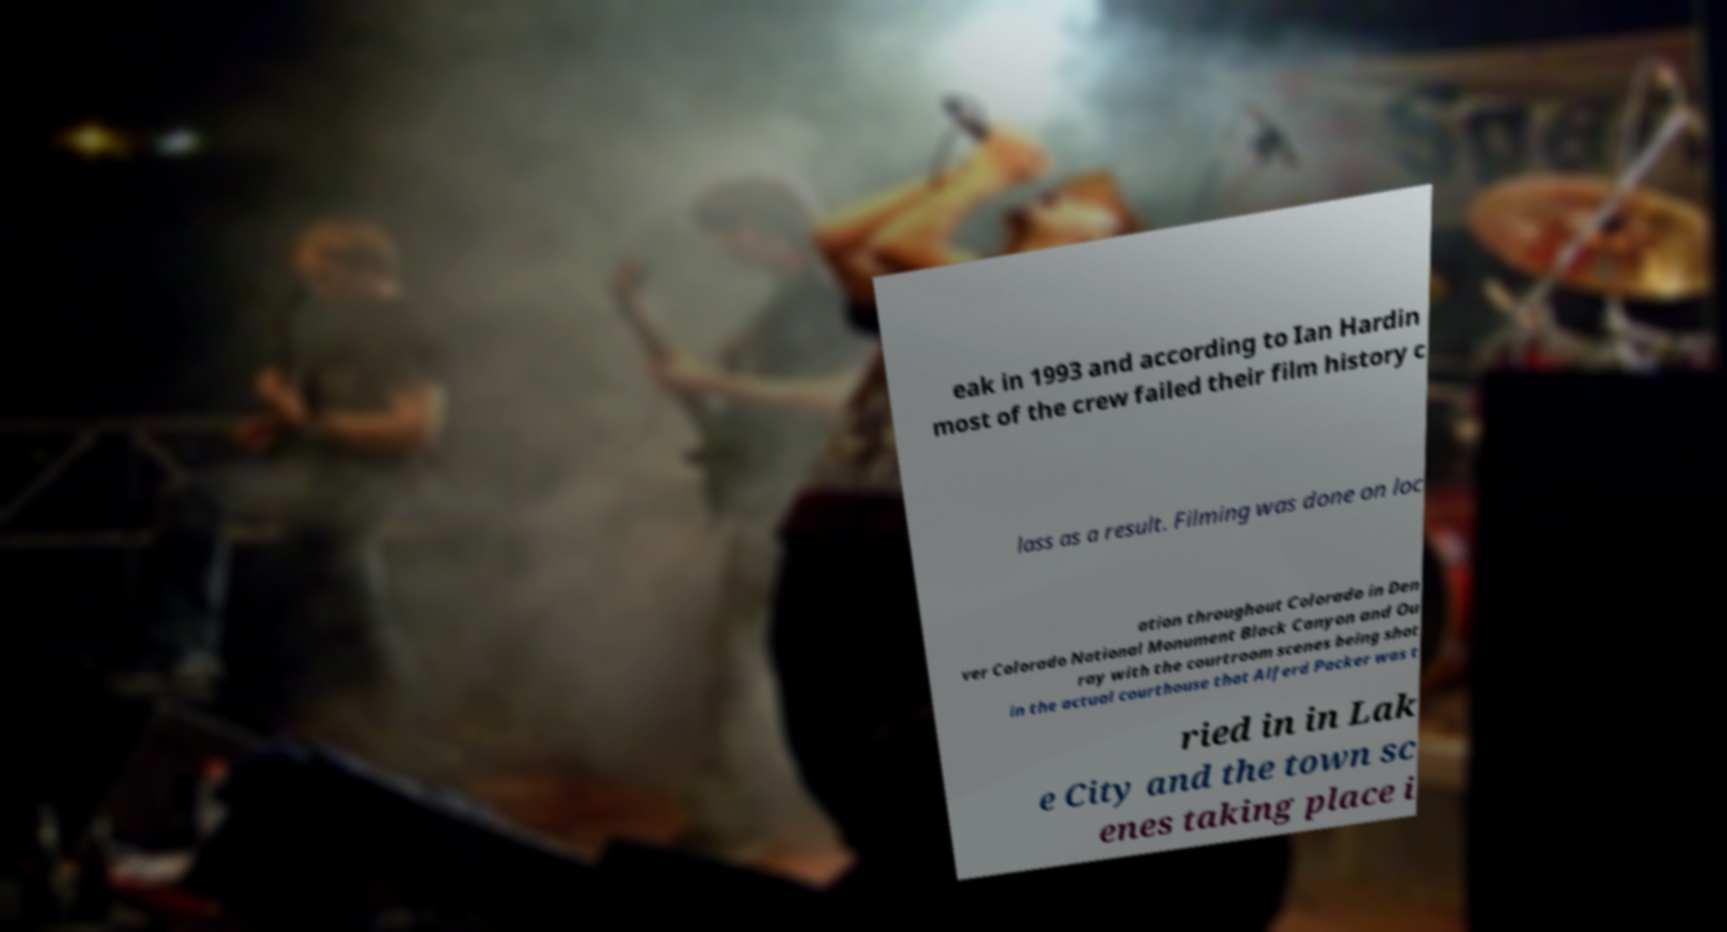Could you extract and type out the text from this image? eak in 1993 and according to Ian Hardin most of the crew failed their film history c lass as a result. Filming was done on loc ation throughout Colorado in Den ver Colorado National Monument Black Canyon and Ou ray with the courtroom scenes being shot in the actual courthouse that Alferd Packer was t ried in in Lak e City and the town sc enes taking place i 